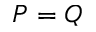Convert formula to latex. <formula><loc_0><loc_0><loc_500><loc_500>P = Q</formula> 